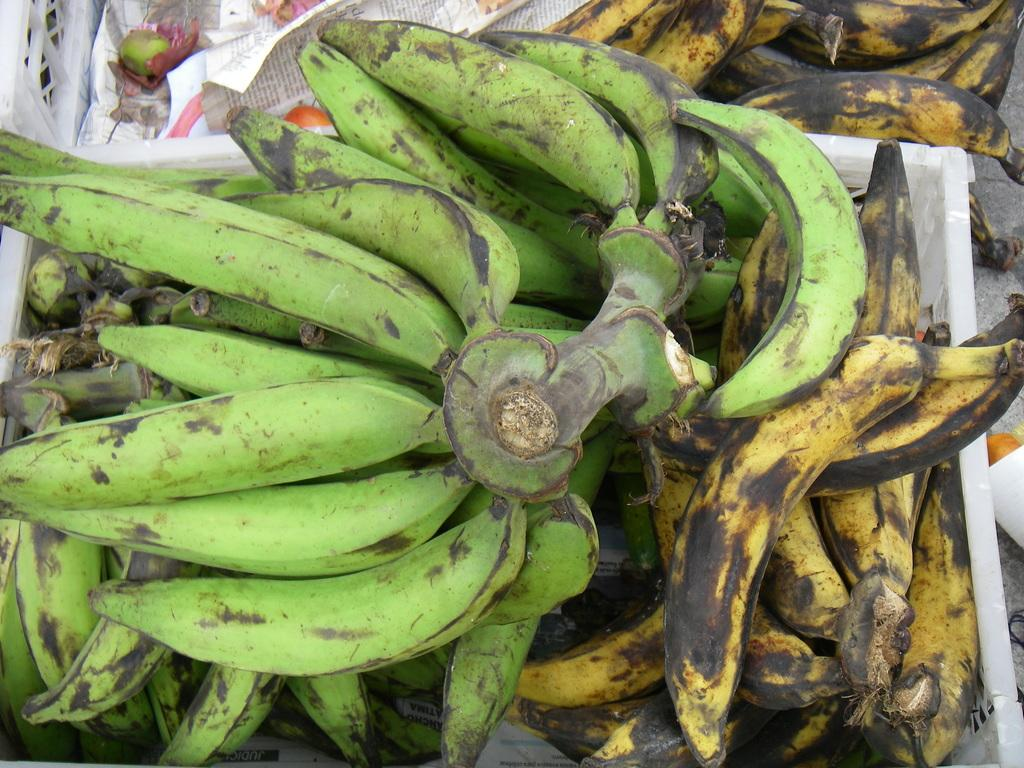What type of fruit is present in the image? There are bananas in the image. Can you describe the condition of some of the bananas? Some of the bananas are ripe, while others are unripe. How are the bananas stored in the image? The bananas are kept in a container. What type of sweater is being worn by the bananas in the image? There are no bananas wearing sweaters in the image; they are simply fruits stored in a container. 